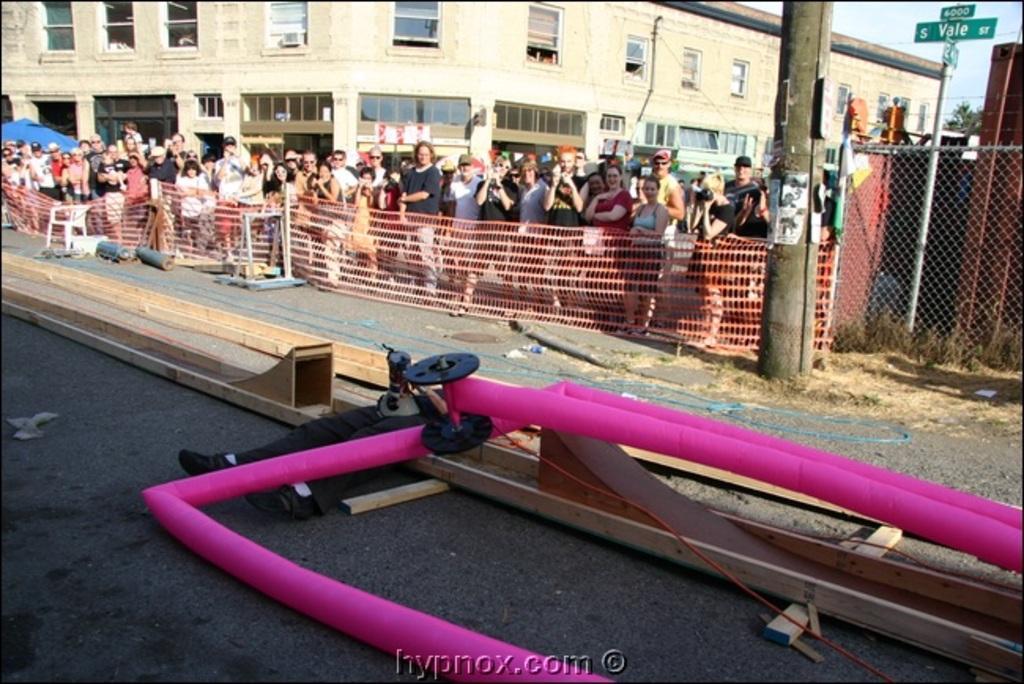Describe this image in one or two sentences. In this image in the front there are wooden stands and there is an object which is pink in colour and there is a person laying on the stand. In the background there are persons standing, there is a fence, building and there are poles and there is a tree. 